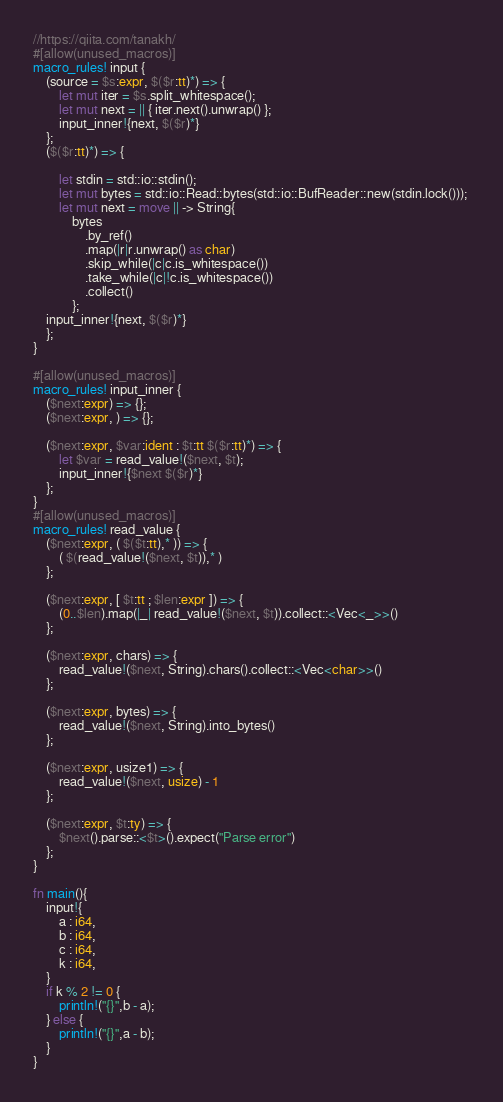Convert code to text. <code><loc_0><loc_0><loc_500><loc_500><_Rust_>//https://qiita.com/tanakh/
#[allow(unused_macros)]
macro_rules! input {
	(source = $s:expr, $($r:tt)*) => {
		let mut iter = $s.split_whitespace();
		let mut next = || { iter.next().unwrap() }; 
		input_inner!{next, $($r)*}
	};
	($($r:tt)*) => {

		let stdin = std::io::stdin();
		let mut bytes = std::io::Read::bytes(std::io::BufReader::new(stdin.lock())); 
		let mut next = move || -> String{
			bytes
				.by_ref()
				.map(|r|r.unwrap() as char) 
				.skip_while(|c|c.is_whitespace()) 
				.take_while(|c|!c.is_whitespace()) 
				.collect()
			};
	input_inner!{next, $($r)*} 
	};
}

#[allow(unused_macros)]
macro_rules! input_inner { 
	($next:expr) => {}; 
	($next:expr, ) => {};

	($next:expr, $var:ident : $t:tt $($r:tt)*) => { 
		let $var = read_value!($next, $t); 
		input_inner!{$next $($r)*}
	}; 
}
#[allow(unused_macros)]
macro_rules! read_value { 
	($next:expr, ( $($t:tt),* )) => {
		( $(read_value!($next, $t)),* ) 
	};
	
	($next:expr, [ $t:tt ; $len:expr ]) => {
		(0..$len).map(|_| read_value!($next, $t)).collect::<Vec<_>>()
	};

	($next:expr, chars) => {
		read_value!($next, String).chars().collect::<Vec<char>>()
	};
	
	($next:expr, bytes) => {
		read_value!($next, String).into_bytes()
	};
	
	($next:expr, usize1) => { 
		read_value!($next, usize) - 1
	};

	($next:expr, $t:ty) => {
		$next().parse::<$t>().expect("Parse error")
	};
}

fn main(){
    input!{
        a : i64,
        b : i64,
        c : i64,
        k : i64,
    }
    if k % 2 != 0 {
        println!("{}",b - a);
    } else {
        println!("{}",a - b);
    }
}</code> 